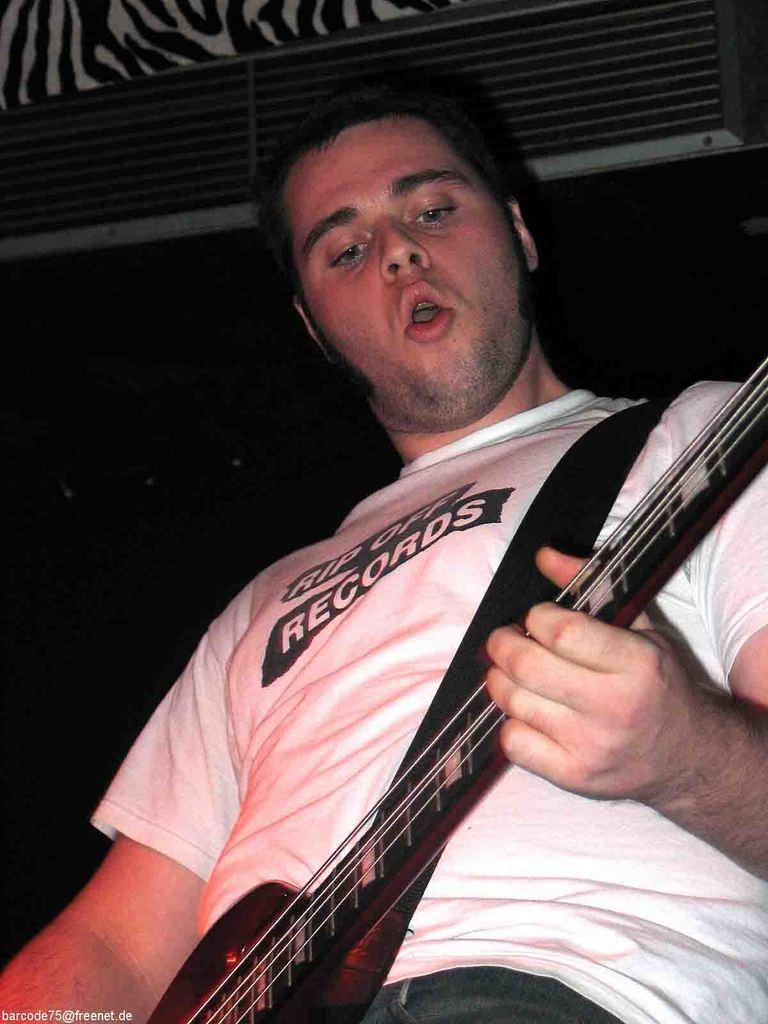Could you give a brief overview of what you see in this image? In the image there is a man singing a song and playing a guitar. 